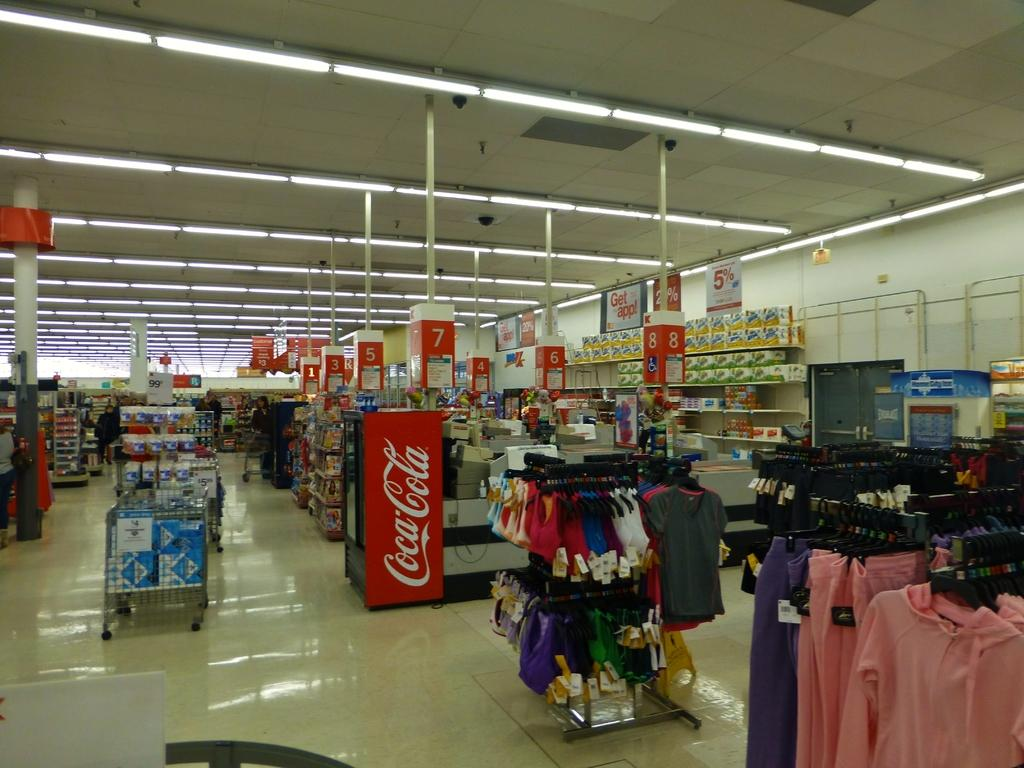Provide a one-sentence caption for the provided image. A big box store with clothing on display and a Coca-cola cooler. 